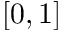Convert formula to latex. <formula><loc_0><loc_0><loc_500><loc_500>[ 0 , 1 ]</formula> 